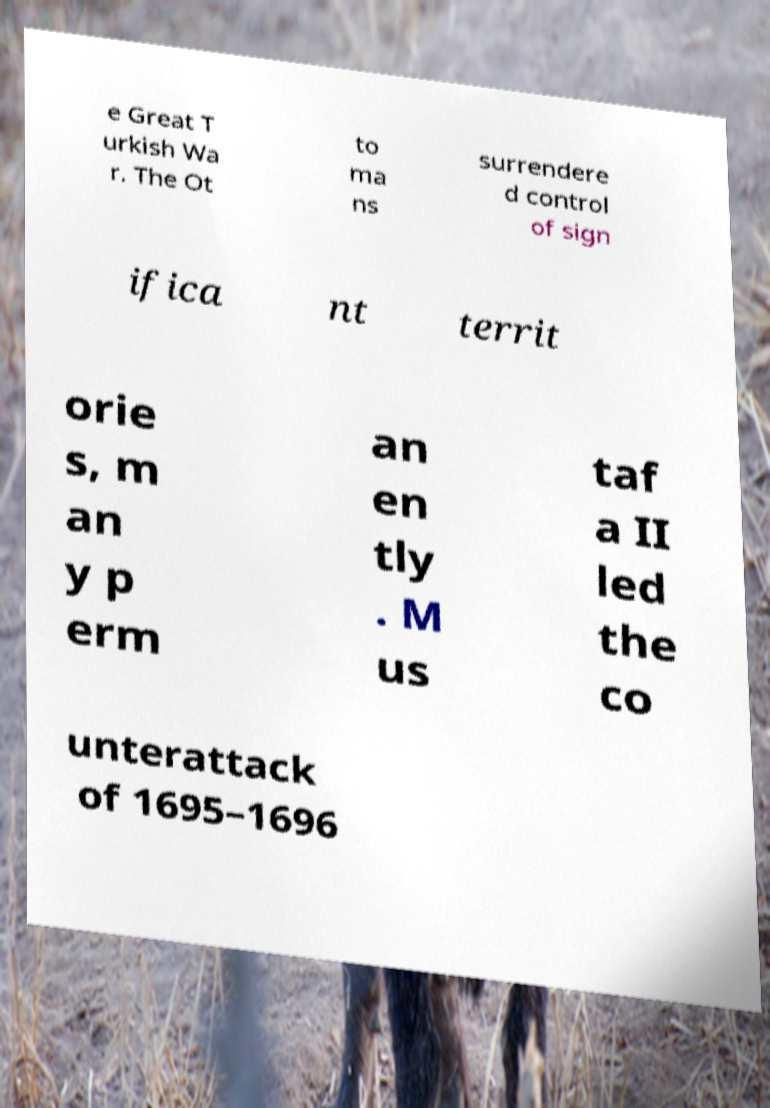Please identify and transcribe the text found in this image. e Great T urkish Wa r. The Ot to ma ns surrendere d control of sign ifica nt territ orie s, m an y p erm an en tly . M us taf a II led the co unterattack of 1695–1696 